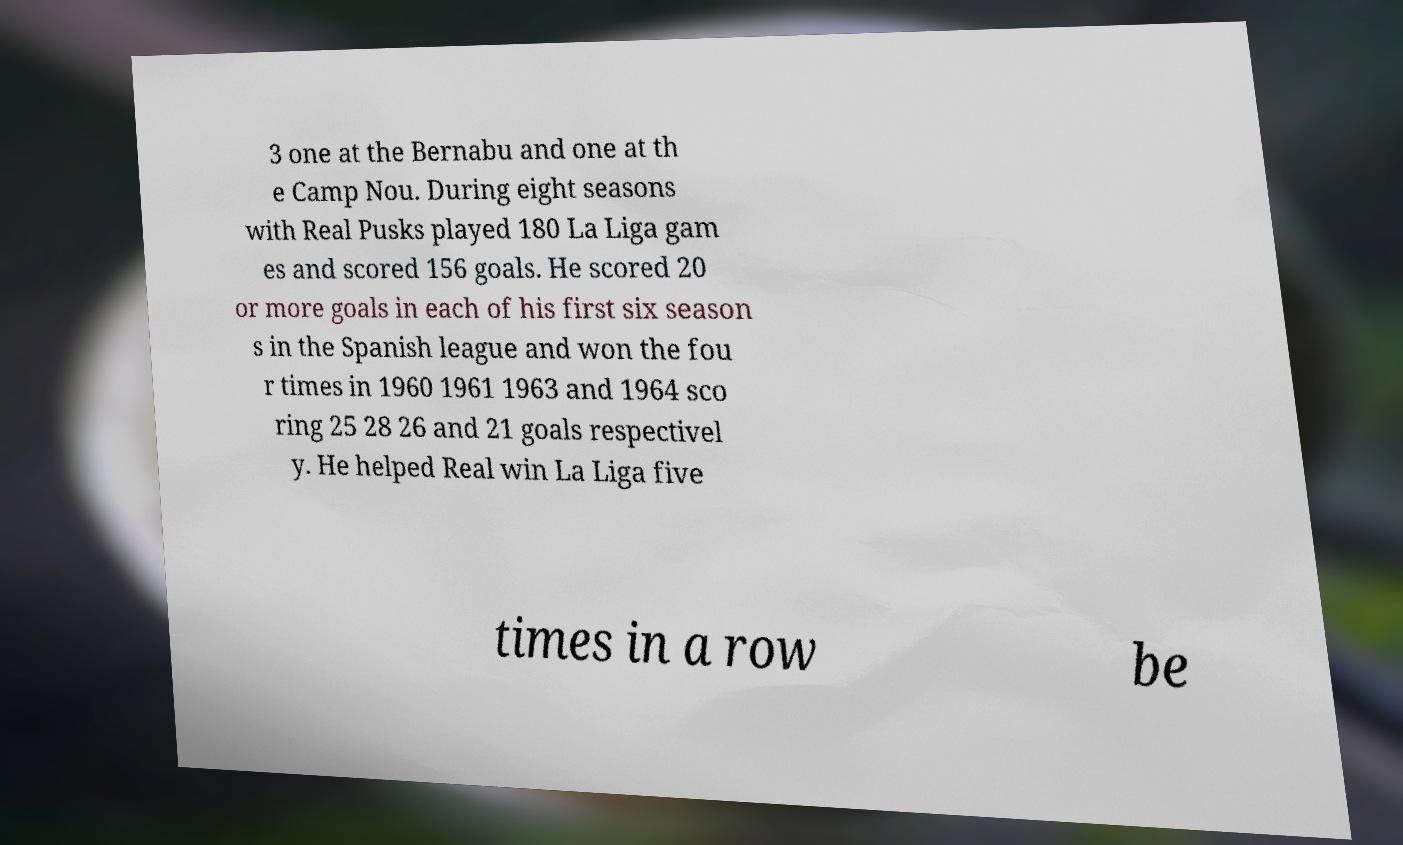Please read and relay the text visible in this image. What does it say? 3 one at the Bernabu and one at th e Camp Nou. During eight seasons with Real Pusks played 180 La Liga gam es and scored 156 goals. He scored 20 or more goals in each of his first six season s in the Spanish league and won the fou r times in 1960 1961 1963 and 1964 sco ring 25 28 26 and 21 goals respectivel y. He helped Real win La Liga five times in a row be 